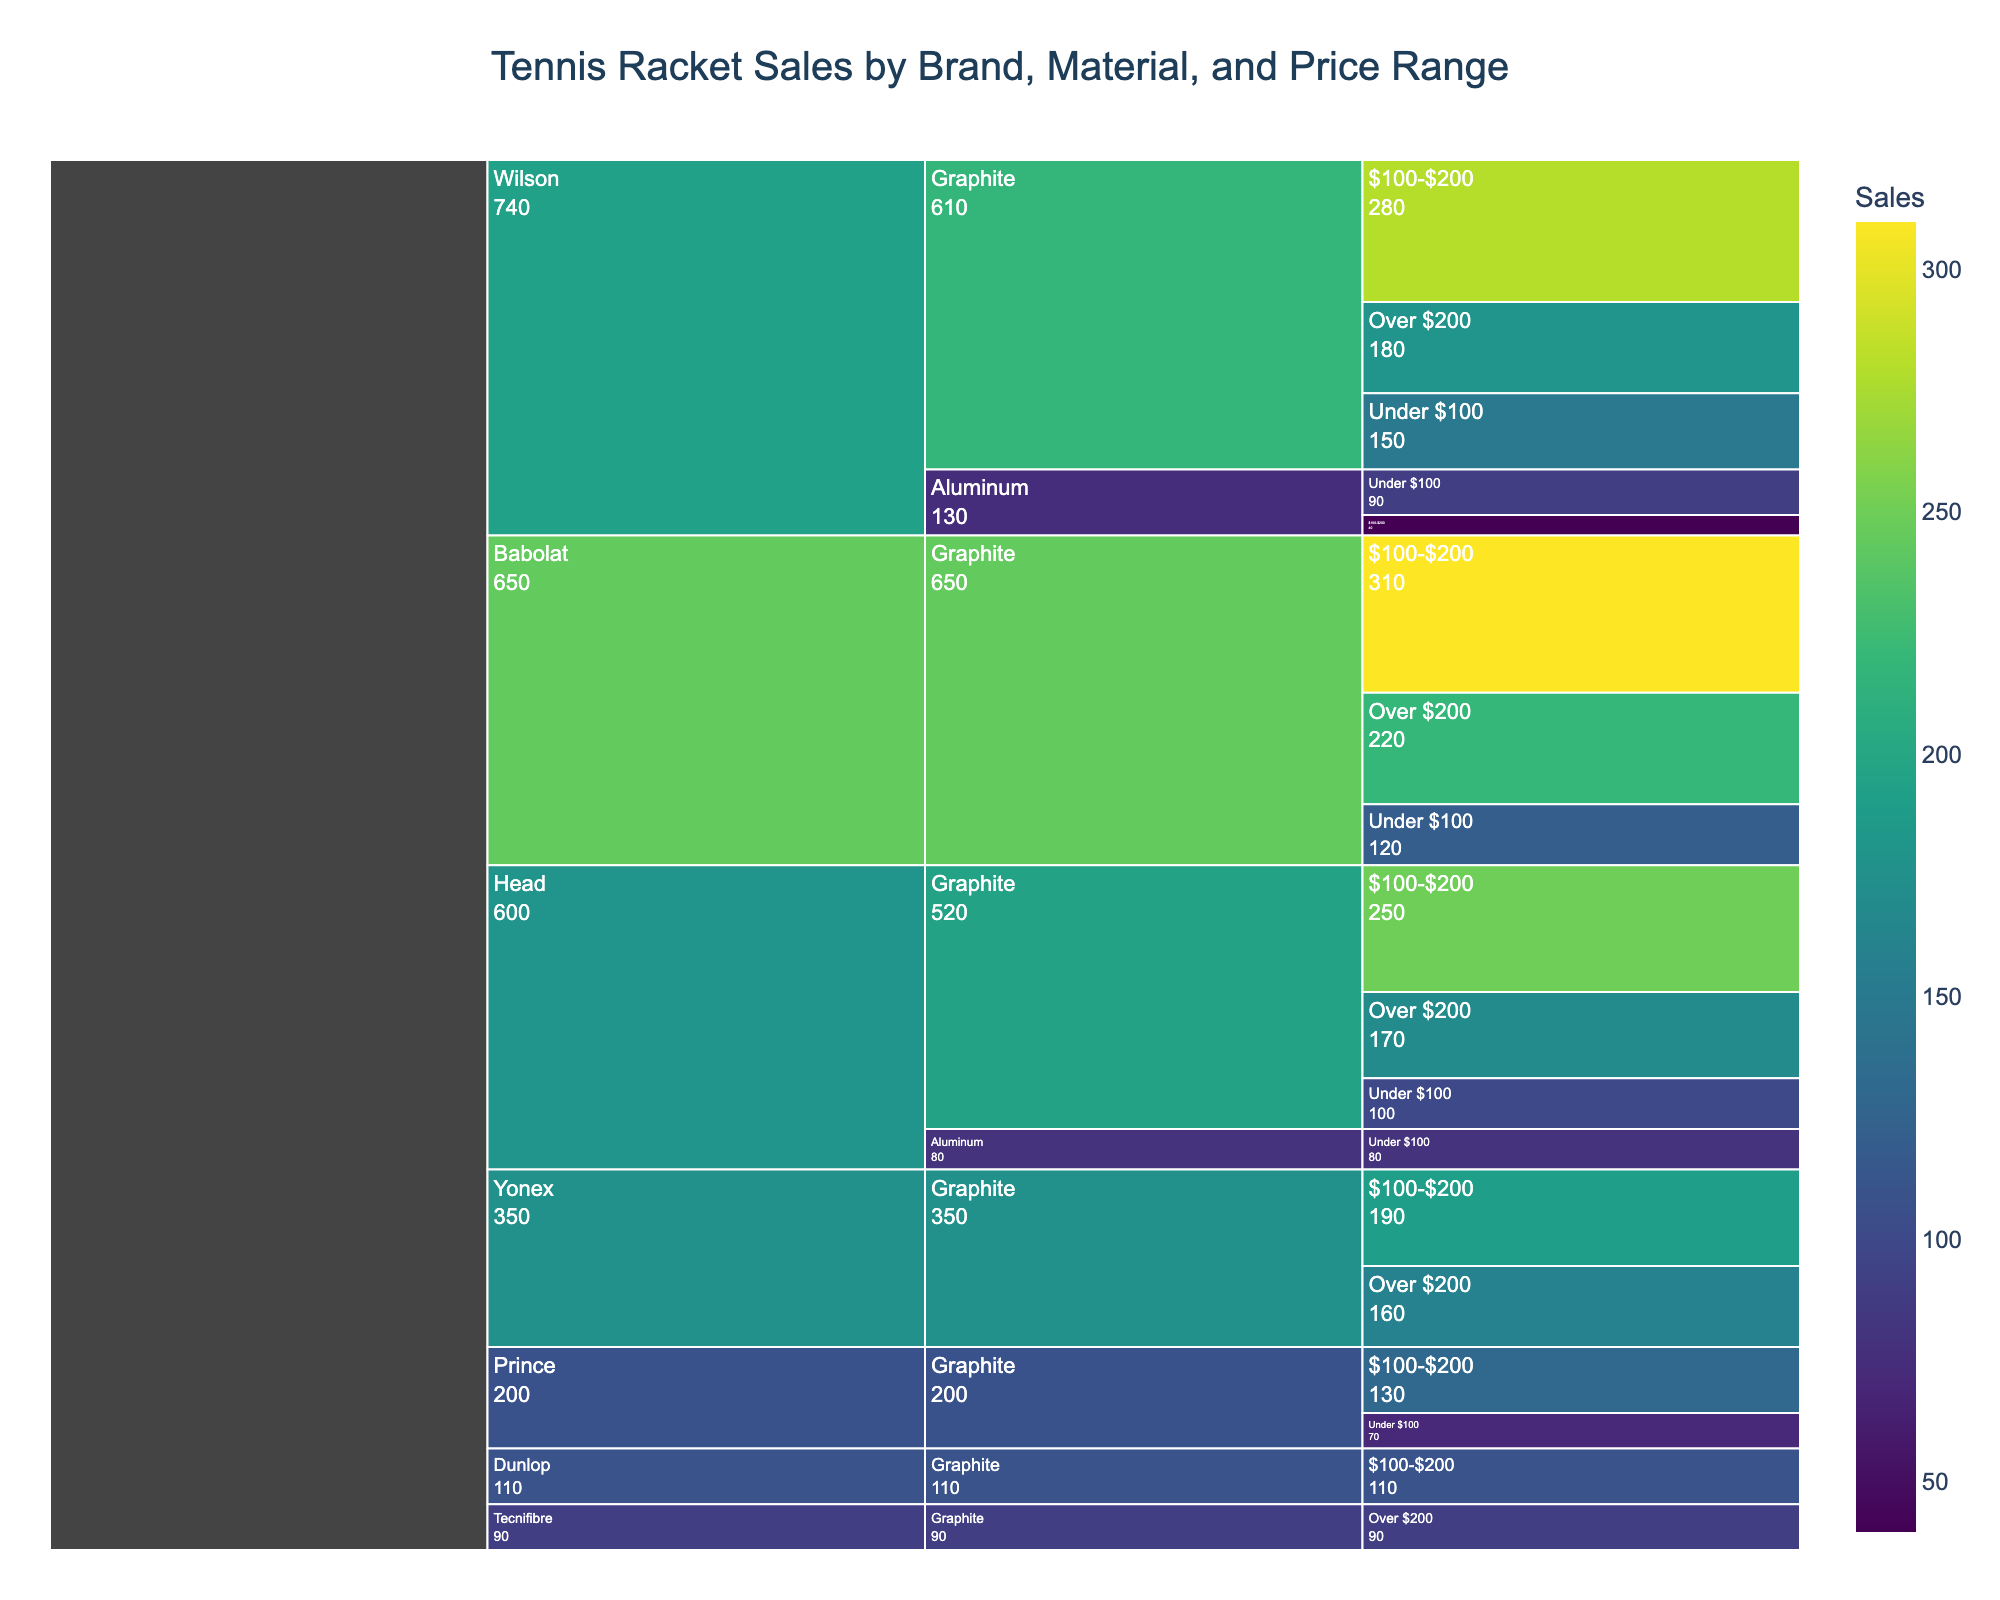How many sales are there for Wilson rackets made of graphite priced between $100 and $200? Look for the 'Wilson' brand, under 'Graphite' material, and find the '100-$200' price range. The number of sales for this category is listed.
Answer: 280 Which brand has the highest sales for rackets priced over $200 made of graphite? Compare the sales of 'Over $200' graphite rackets across different brands. Identify the brand with the highest number in this category.
Answer: Babolat What are the total sales for Head rackets summarized across all categories? Find the sales numbers for all categories under the 'Head' brand, and sum them up: 100 (Under $100, Graphite) + 250 ($100-$200, Graphite) + 170 (Over $200, Graphite) + 80 (Under $100, Aluminum) = 600.
Answer: 600 Which price range has the least number of sales for Yonex graphite rackets? Look at the different price ranges for 'Yonex' under 'Graphite' material and compare the sales figures.
Answer: Over $200 Are aluminum rackets or graphite rackets more popular for the Wilson brand in the '$100-$200' price range? Look at the sales numbers for Wilson brand, comparing 'Aluminum' and 'Graphite' materials in the '$100-$200' price range. Sales for Graphite are 280 whereas Aluminum is 40.
Answer: Graphite What are the total sales for Babolat rackets priced under $100? Look for 'Babolat' under 'Graphite' material and 'Under $100' price range, and identify the number of sales listed.
Answer: 120 Which brand has the least sales for rackets made with graphite? Sum up the sales for graphite material for each brand and compare. Prince has the least: 70 (Under $100) + 130 ($100-$200) = 200.
Answer: Prince What is the average sales figure for Wilson aluminum rackets across all price ranges? Add up the sales for Wilson Aluminum rackets: 90 (Under $100) + 40 ($100-$200) = 130. Calculate the average: 130 / 2 = 65.
Answer: 65 In the price range '$100-$200', which brand has the second-highest sales for graphite rackets? List the sales figures for all brands with graphite rackets in '$100-$200' and identify the second-highest figure. Babolat (310) is the highest, so Wilson (280) is the second-highest.
Answer: Wilson 